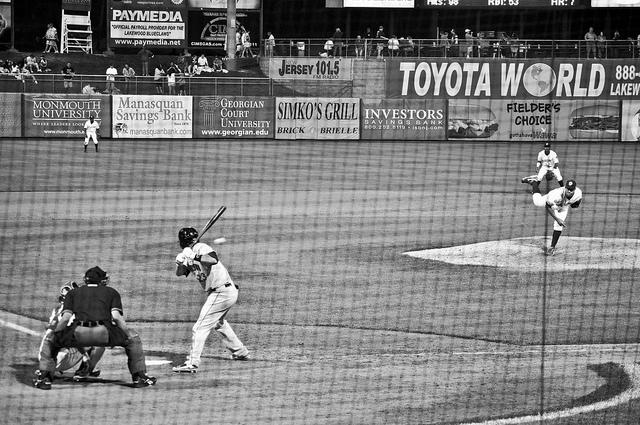What state is this field most likely in?

Choices:
A) kansas
B) maine
C) florida
D) new jersey new jersey 